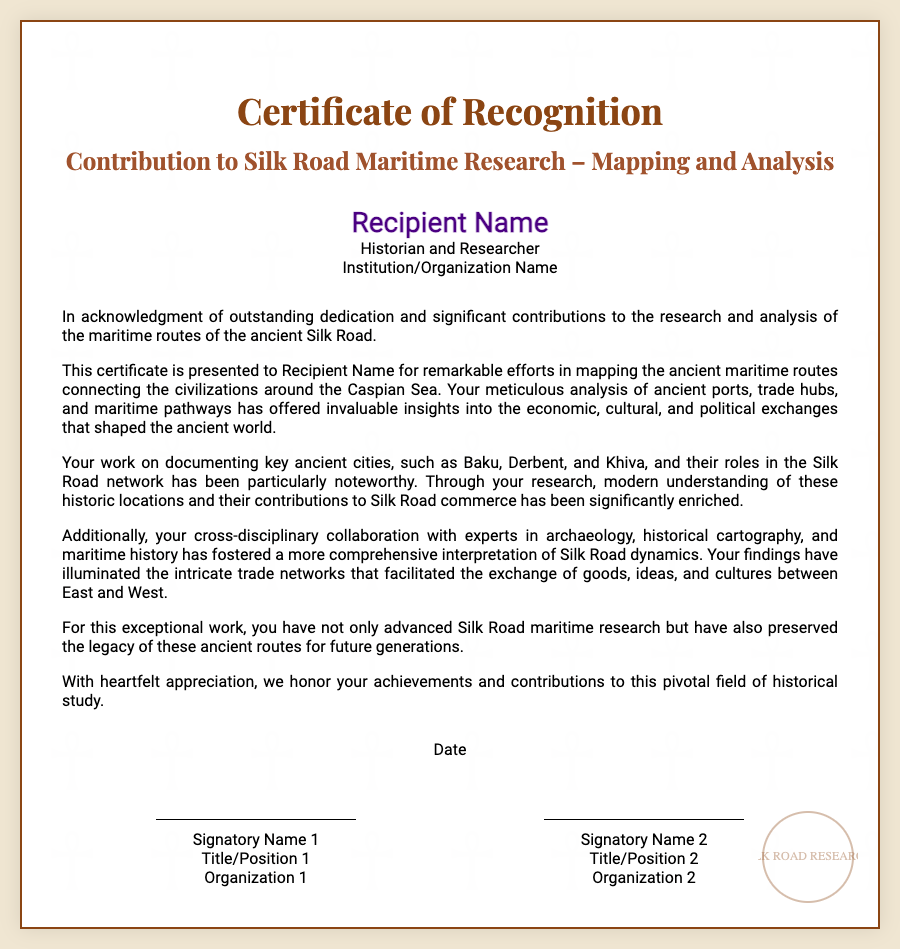What is the title of the certificate? The title of the certificate is presented prominently in the document as "Contribution to Silk Road Maritime Research – Mapping and Analysis."
Answer: Contribution to Silk Road Maritime Research – Mapping and Analysis Who is the recipient of the certificate? The specific individual recognized by the certificate is mentioned in the "recipient-name" section.
Answer: Recipient Name What are some of the ancient cities documented in the research? The document references key ancient cities related to Silk Road research, specifically naming a few.
Answer: Baku, Derbent, and Khiva What is acknowledged as a significant aspect of the recipient's work? The document highlights the recipient's efforts in a specific area of research that is influential in understanding ancient trade routes.
Answer: Mapping the ancient maritime routes What is the date mentioned in the certificate? The document indicates that there is a "Date" section included where the specific date of the recognition can be noted.
Answer: Date Who are the signatories on the certificate? The certificate contains sections for two signatories who are involved in the recognition.
Answer: Signatory Name 1 and Signatory Name 2 What type of collaboration is emphasized in the certificate? The document mentions the type of collaboration that enhanced the recipient's research efforts.
Answer: Cross-disciplinary collaboration Why is the recipient’s work considered to have advanced Silk Road maritime research? The reasoning highlights how the recipient's contributions have enhanced understanding in a specific area of historical study.
Answer: Illuminated the intricate trade networks What does the certificate symbolize in relation to historical study? The document articulates the importance of the recipient’s contributions to the preservation of historical legacy.
Answer: Preserved the legacy of these ancient routes 